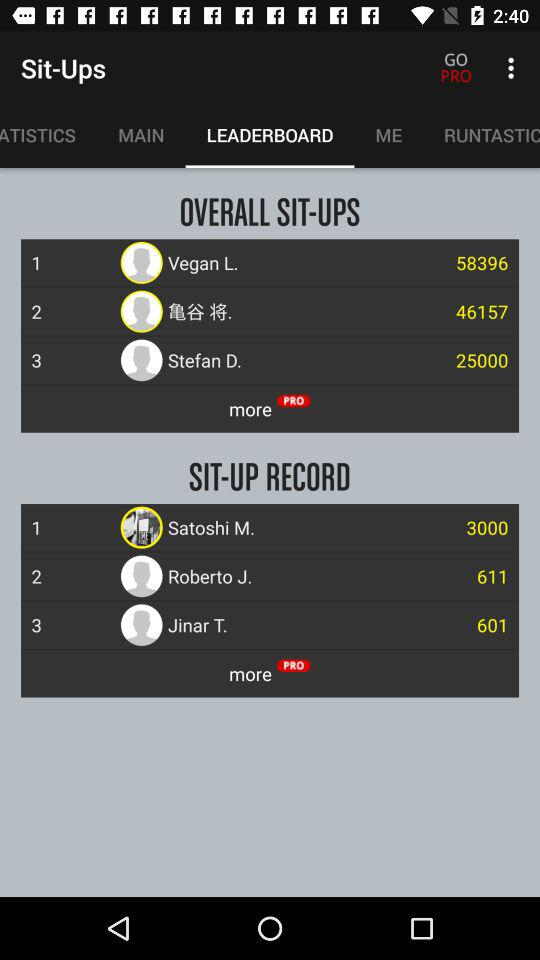What is the sit-up record of Roberto J.? The sit-up record is 611. 